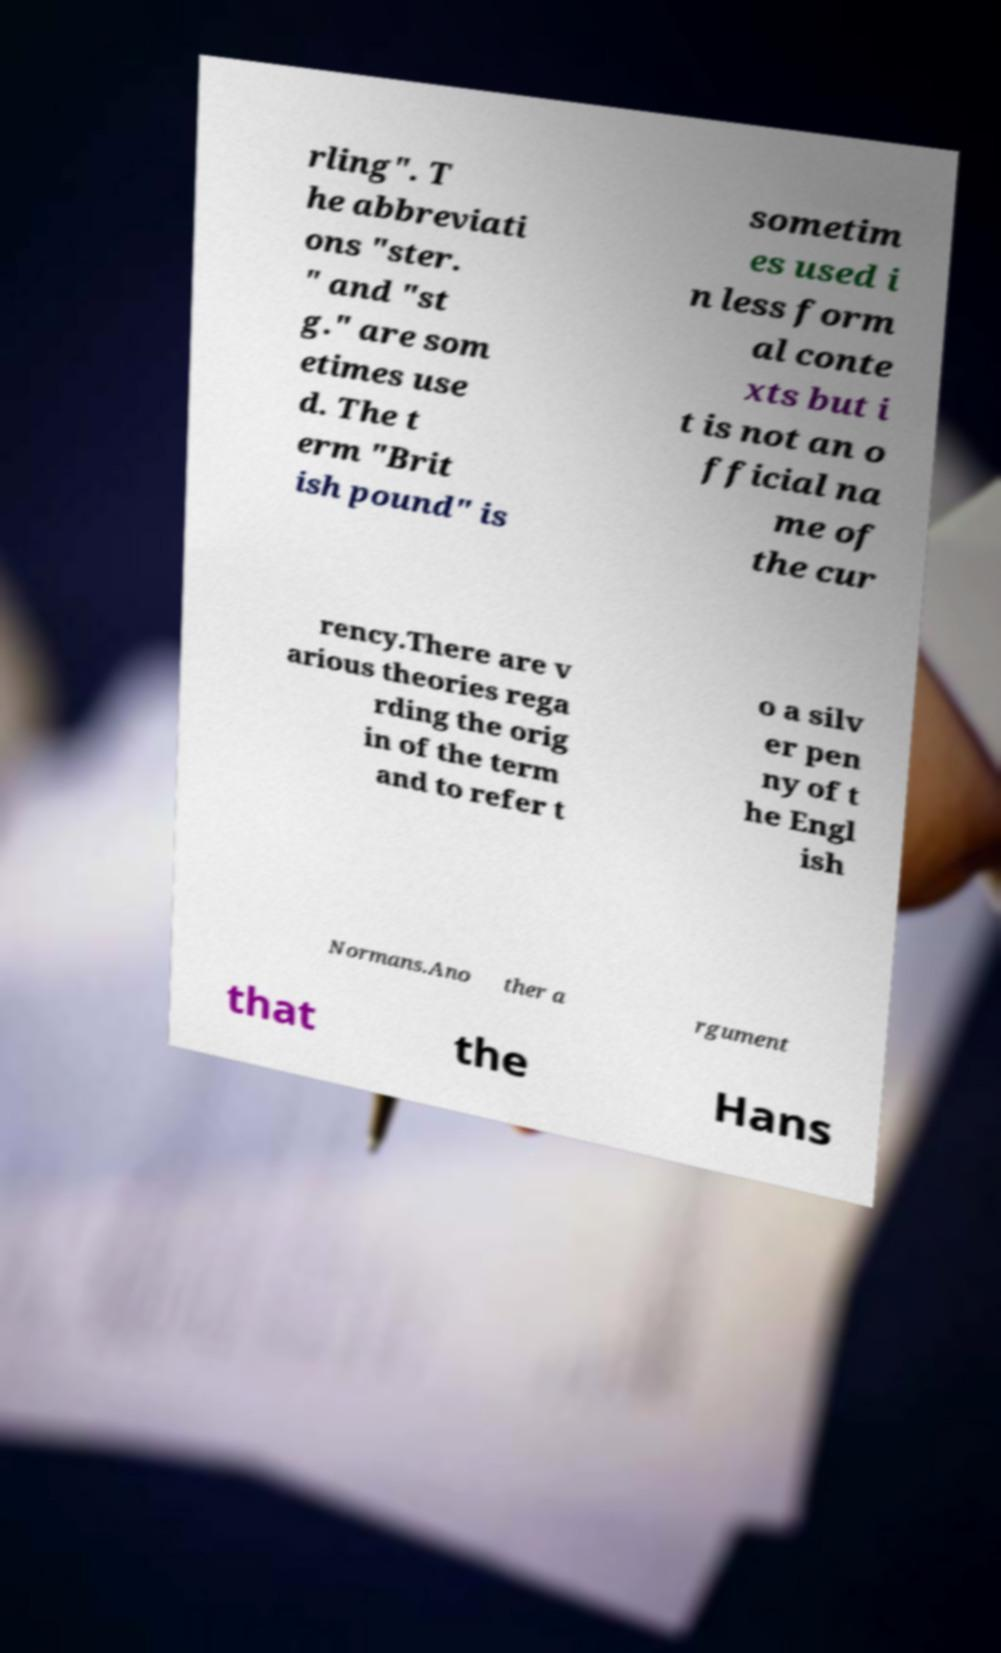Could you assist in decoding the text presented in this image and type it out clearly? rling". T he abbreviati ons "ster. " and "st g." are som etimes use d. The t erm "Brit ish pound" is sometim es used i n less form al conte xts but i t is not an o fficial na me of the cur rency.There are v arious theories rega rding the orig in of the term and to refer t o a silv er pen ny of t he Engl ish Normans.Ano ther a rgument that the Hans 